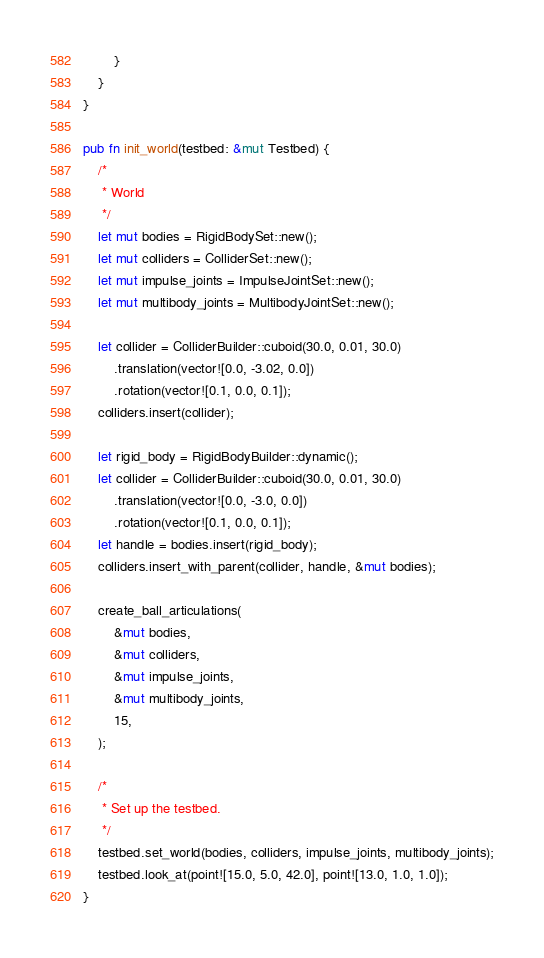Convert code to text. <code><loc_0><loc_0><loc_500><loc_500><_Rust_>        }
    }
}

pub fn init_world(testbed: &mut Testbed) {
    /*
     * World
     */
    let mut bodies = RigidBodySet::new();
    let mut colliders = ColliderSet::new();
    let mut impulse_joints = ImpulseJointSet::new();
    let mut multibody_joints = MultibodyJointSet::new();

    let collider = ColliderBuilder::cuboid(30.0, 0.01, 30.0)
        .translation(vector![0.0, -3.02, 0.0])
        .rotation(vector![0.1, 0.0, 0.1]);
    colliders.insert(collider);

    let rigid_body = RigidBodyBuilder::dynamic();
    let collider = ColliderBuilder::cuboid(30.0, 0.01, 30.0)
        .translation(vector![0.0, -3.0, 0.0])
        .rotation(vector![0.1, 0.0, 0.1]);
    let handle = bodies.insert(rigid_body);
    colliders.insert_with_parent(collider, handle, &mut bodies);

    create_ball_articulations(
        &mut bodies,
        &mut colliders,
        &mut impulse_joints,
        &mut multibody_joints,
        15,
    );

    /*
     * Set up the testbed.
     */
    testbed.set_world(bodies, colliders, impulse_joints, multibody_joints);
    testbed.look_at(point![15.0, 5.0, 42.0], point![13.0, 1.0, 1.0]);
}
</code> 